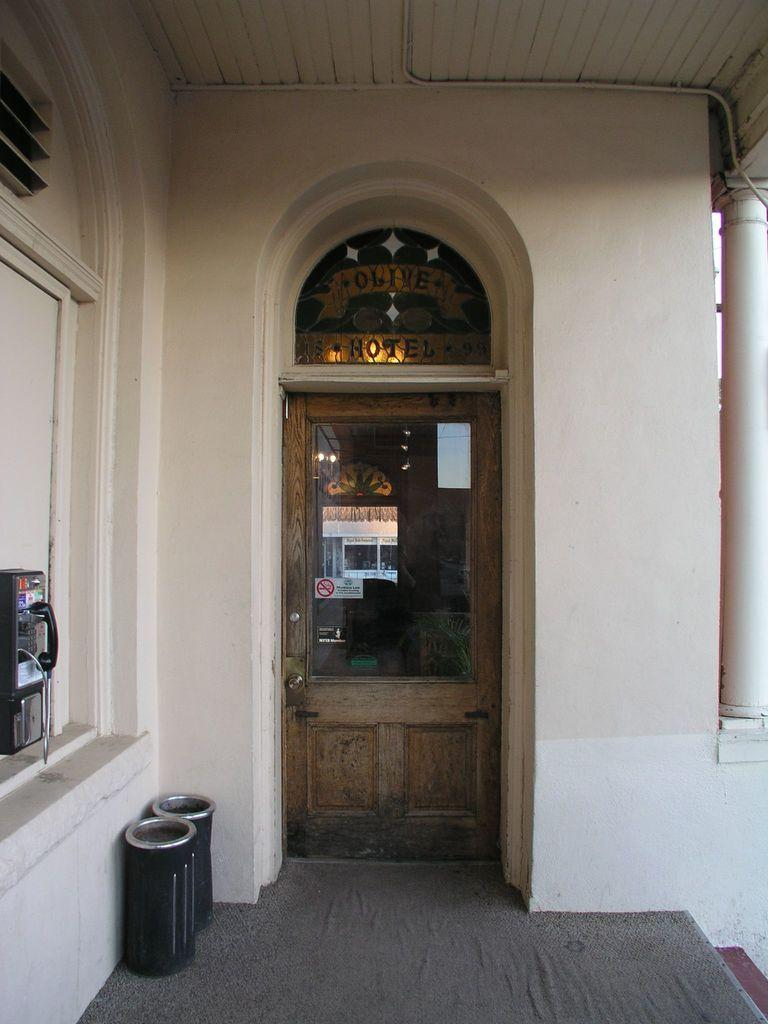What is the main structure in the center of the image? There is a door in the center of the image. What other architectural element is present in the image? There is a wall in the image. What can be seen on the left side of the image? There are bins on the left side of the image. What is attached to the wall in the image? There is a phone box on the wall. What is visible at the top of the image? The ceiling is visible at the top of the image. What type of silk fabric is draped over the stage in the image? There is no silk fabric or stage present in the image. What is the main character's desire in the image? There is no character or desire depicted in the image; it features a door, wall, bins, phone box, and ceiling. 